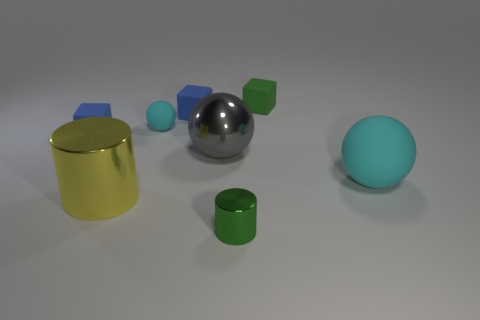Subtract all large cyan spheres. How many spheres are left? 2 Add 1 big cyan objects. How many objects exist? 9 Subtract 1 cylinders. How many cylinders are left? 1 Subtract all green cubes. How many cubes are left? 2 Subtract 1 gray spheres. How many objects are left? 7 Subtract all blocks. How many objects are left? 5 Subtract all gray cubes. Subtract all brown cylinders. How many cubes are left? 3 Subtract all yellow blocks. How many brown cylinders are left? 0 Subtract all tiny balls. Subtract all blue objects. How many objects are left? 5 Add 7 tiny cyan matte spheres. How many tiny cyan matte spheres are left? 8 